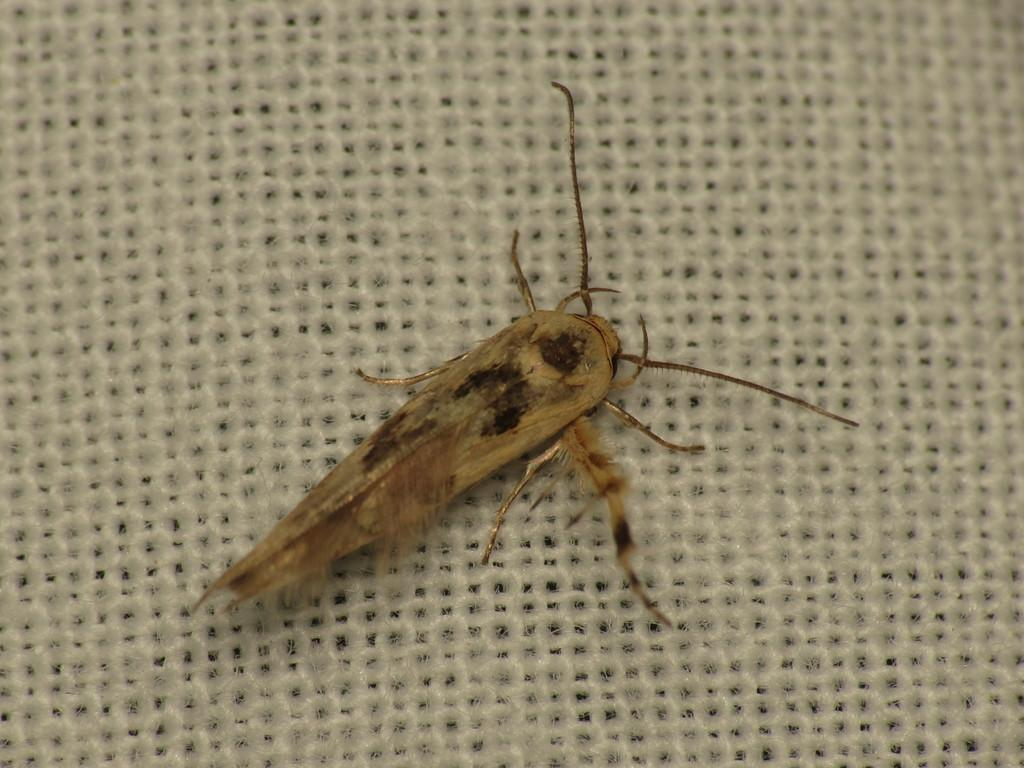What type of creature is present in the image? There is an insect in the image. Can you describe the insect's location in the image? The insect is on an object. What type of pump can be seen in the image? There is no pump present in the image. What type of harmony is the insect creating with the object in the image? The insect is not creating any harmony with the object in the image. 